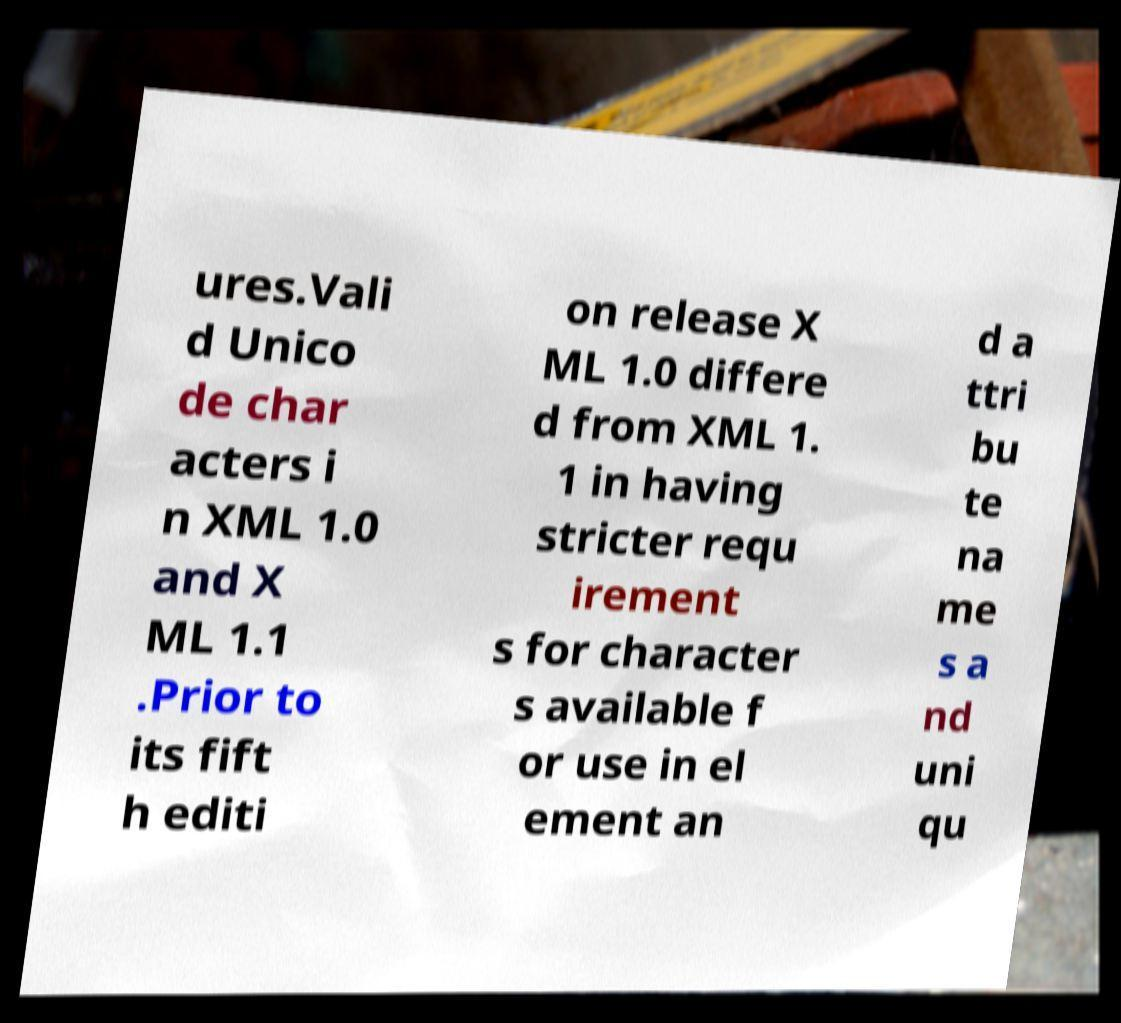What messages or text are displayed in this image? I need them in a readable, typed format. ures.Vali d Unico de char acters i n XML 1.0 and X ML 1.1 .Prior to its fift h editi on release X ML 1.0 differe d from XML 1. 1 in having stricter requ irement s for character s available f or use in el ement an d a ttri bu te na me s a nd uni qu 